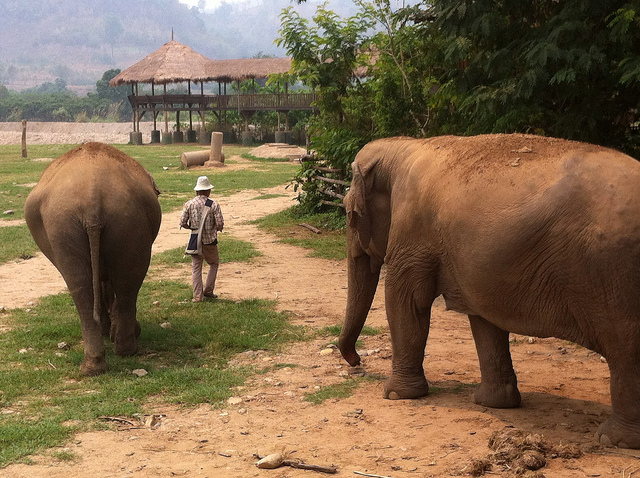What type of environment are the elephants in, and does it appear to be a natural habitat or a sanctuary? The elephants are in a spacious and open environment with natural soil underfoot and a large thatched pavilion in the background. While it has elements that mimic a natural habitat, the presence of structural features like the pavilion suggests it may be a sanctuary designed to give the impression of a natural setting while providing care for the animals. How do the elephants appear to be? Are they showing any signs of distress or are they relaxed? The elephants seem to be at ease, showing no immediate signs of distress. Their posture is relaxed, and they are allowing the close presence of the human, indicating they are accustomed to interaction and are likely well cared for in a safe and controlled environment. 